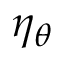<formula> <loc_0><loc_0><loc_500><loc_500>\eta _ { \theta }</formula> 